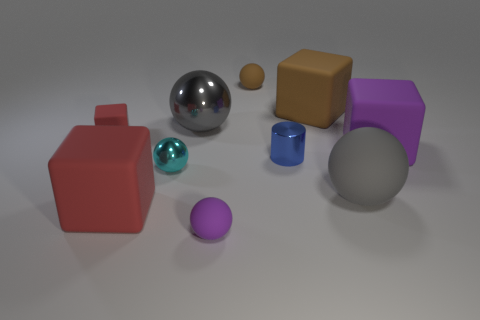What is the shape of the large object that is both to the left of the blue cylinder and in front of the cyan ball?
Your answer should be very brief. Cube. Are there any large brown blocks made of the same material as the big red object?
Keep it short and to the point. Yes. What material is the thing that is the same color as the small matte cube?
Your response must be concise. Rubber. Is the purple object to the right of the large brown block made of the same material as the large sphere that is behind the purple rubber block?
Keep it short and to the point. No. Is the number of purple rubber cylinders greater than the number of big rubber blocks?
Provide a short and direct response. No. There is a big rubber thing in front of the gray thing that is in front of the big ball behind the big purple rubber object; what is its color?
Keep it short and to the point. Red. There is a small matte sphere that is in front of the tiny red matte block; does it have the same color as the large ball that is in front of the purple rubber cube?
Your response must be concise. No. There is a tiny matte ball that is behind the small shiny cylinder; how many big brown matte blocks are on the right side of it?
Provide a succinct answer. 1. Are there any metal cylinders?
Your answer should be compact. Yes. How many other objects are the same color as the tiny cylinder?
Make the answer very short. 0. 